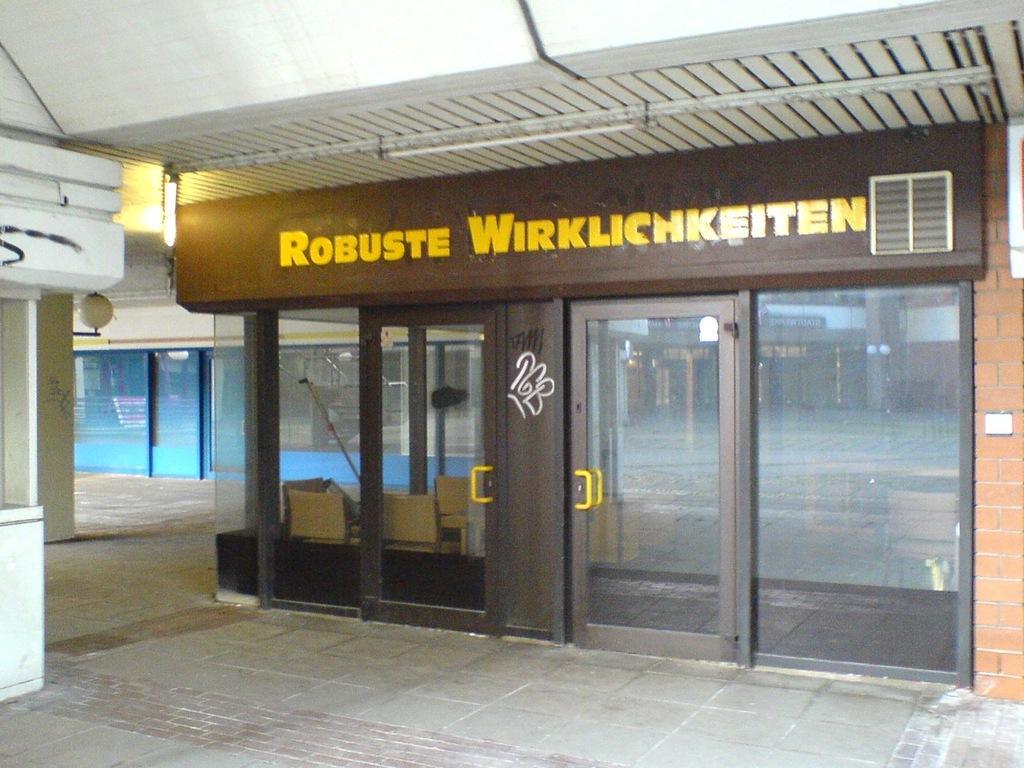In one or two sentences, can you explain what this image depicts? In the image there is a store with glass doors and a name on it. On the right corner of the image there is a pillar. And in the background there are stores with glass doors. And on the left corner of the image there is a wall and a pillar. At the bottom of the image there is a floor. 